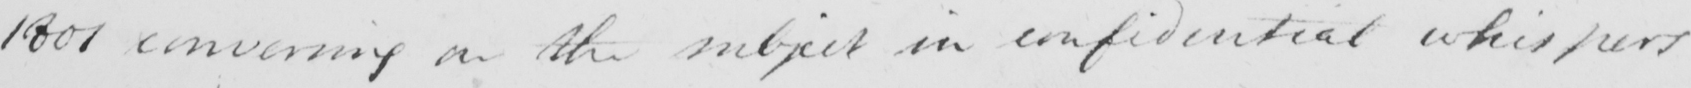Transcribe the text shown in this historical manuscript line. 1801 conversing on the subject in confidential whispers 